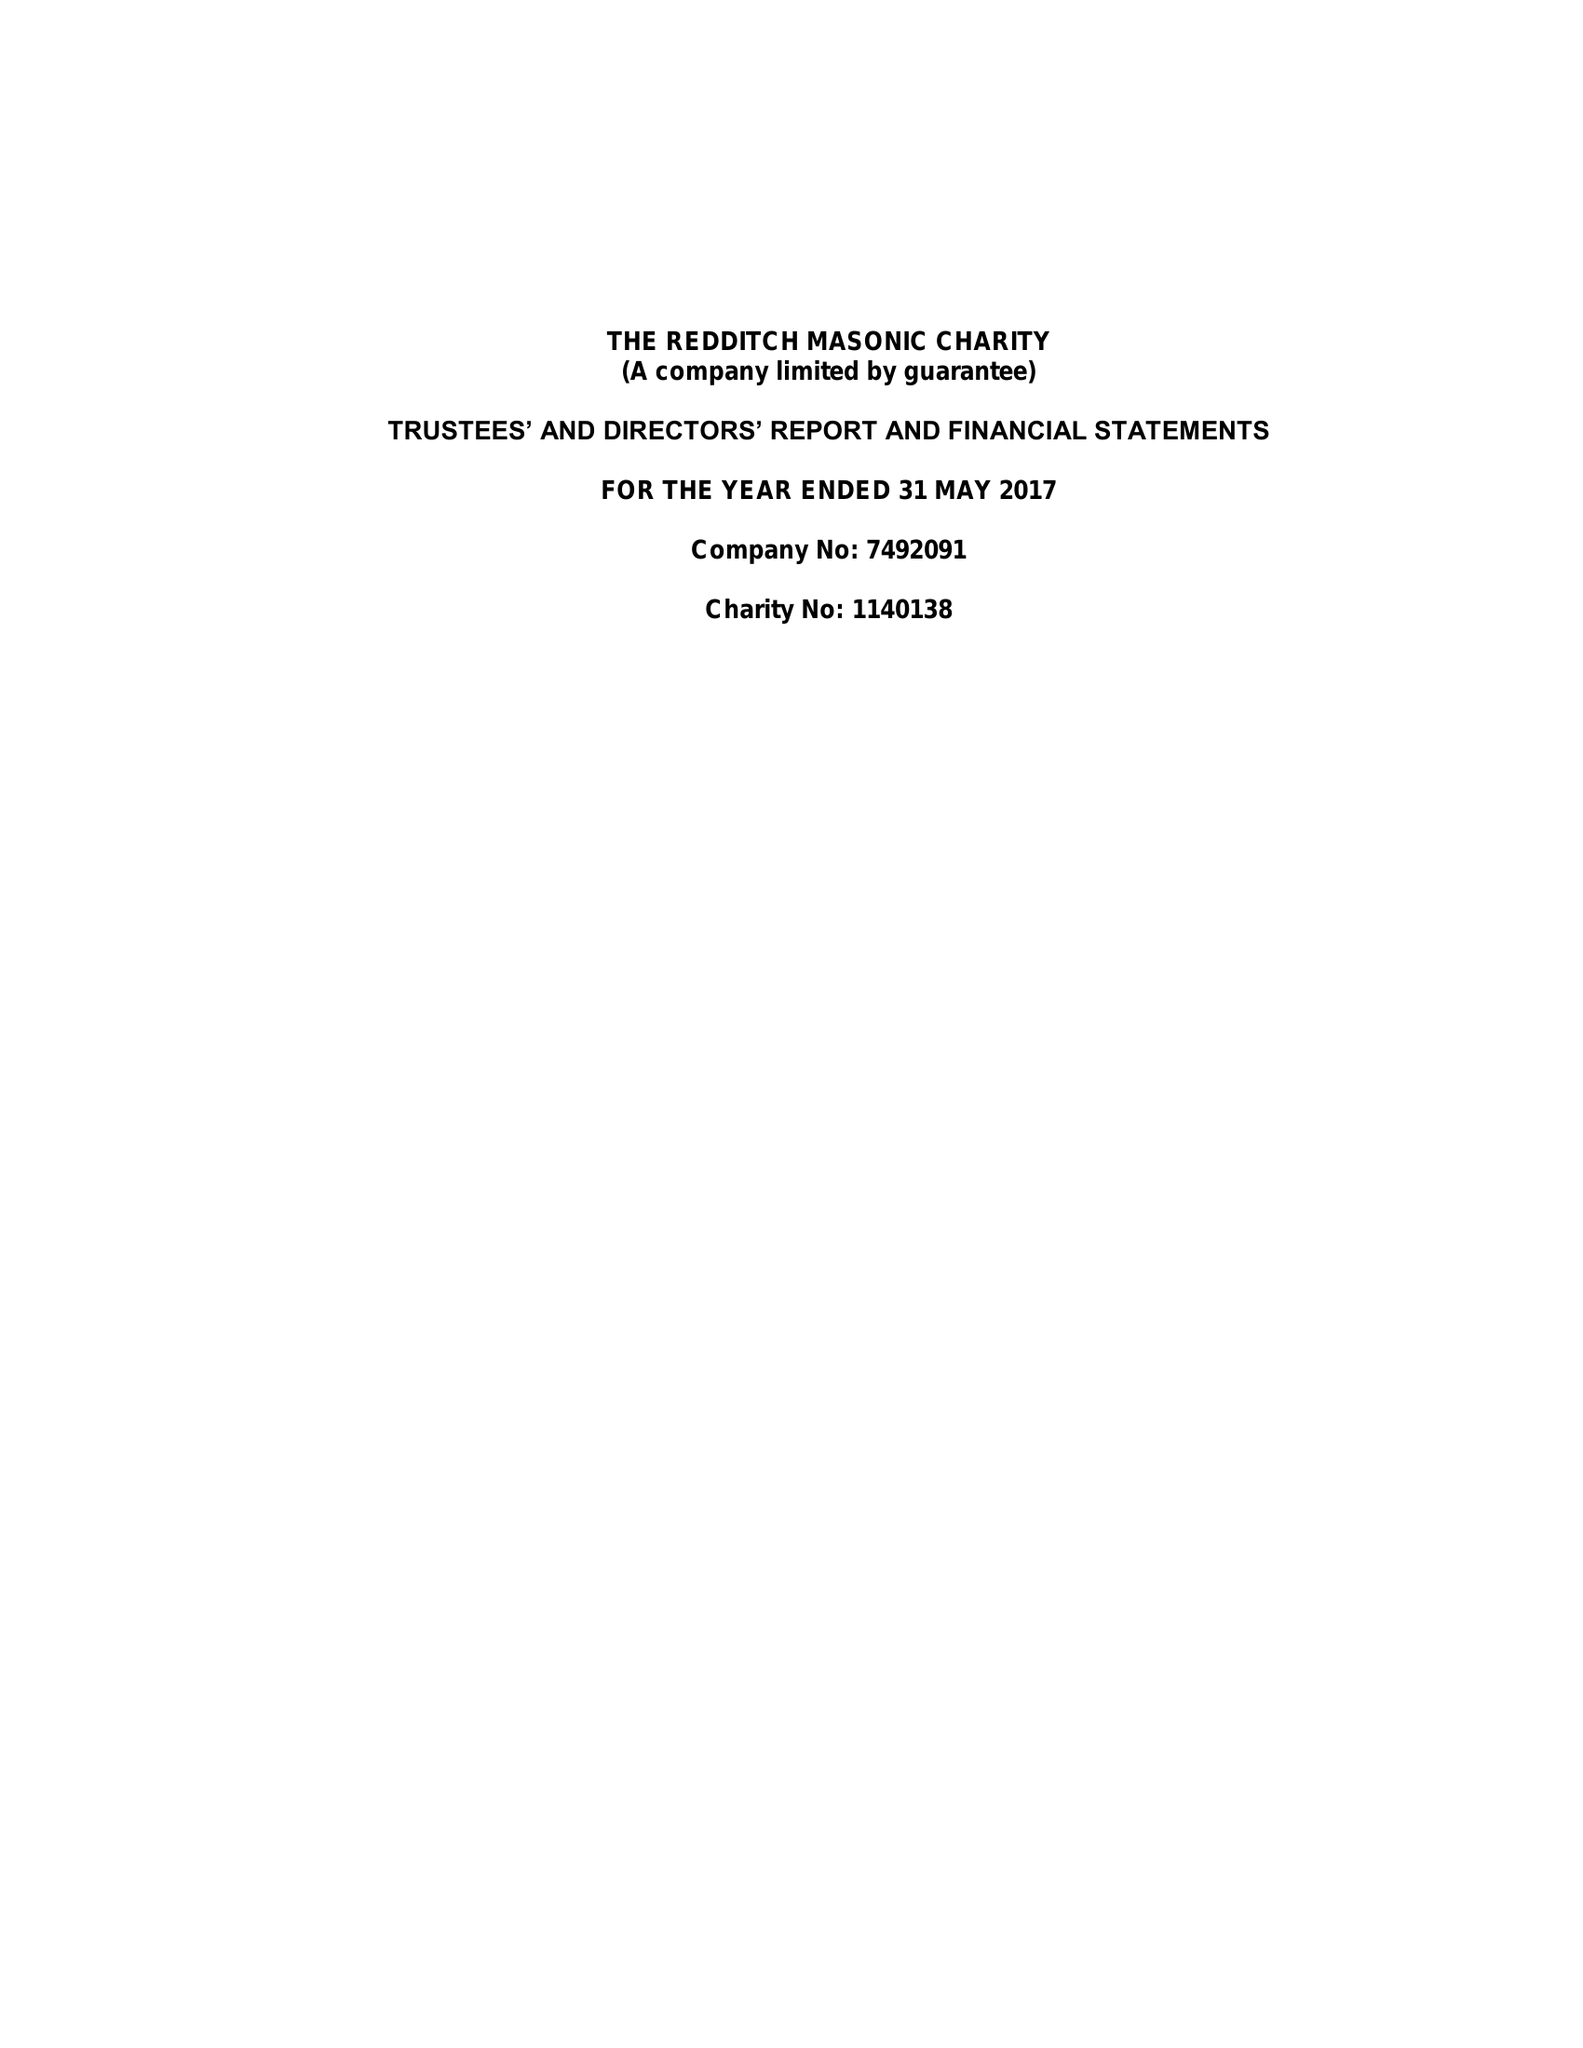What is the value for the address__post_town?
Answer the question using a single word or phrase. REDDITCH 